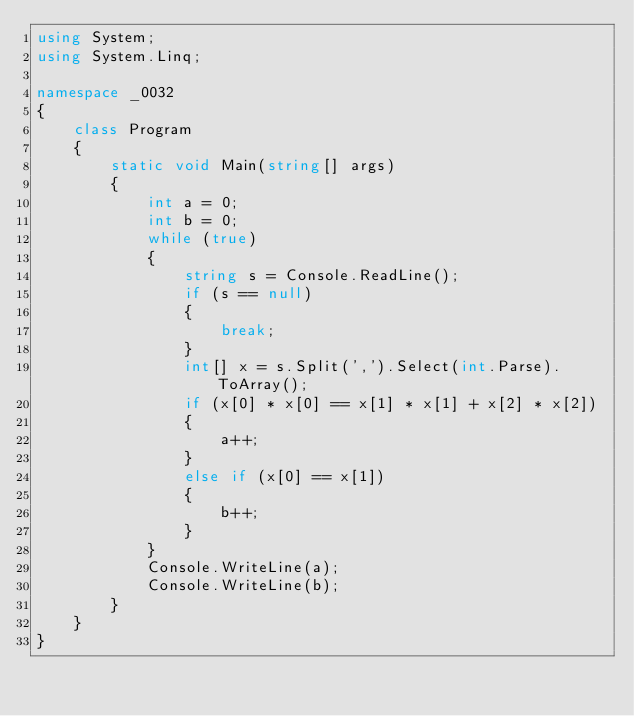<code> <loc_0><loc_0><loc_500><loc_500><_C#_>using System;
using System.Linq;

namespace _0032
{
    class Program
    {
        static void Main(string[] args)
        {
            int a = 0;
            int b = 0;
            while (true)
            {
                string s = Console.ReadLine();
                if (s == null)
                {
                    break;
                }
                int[] x = s.Split(',').Select(int.Parse).ToArray();
                if (x[0] * x[0] == x[1] * x[1] + x[2] * x[2])
                {
                    a++;
                }
                else if (x[0] == x[1])
                {
                    b++;
                }
            }
            Console.WriteLine(a);
            Console.WriteLine(b);
        }
    }
}</code> 